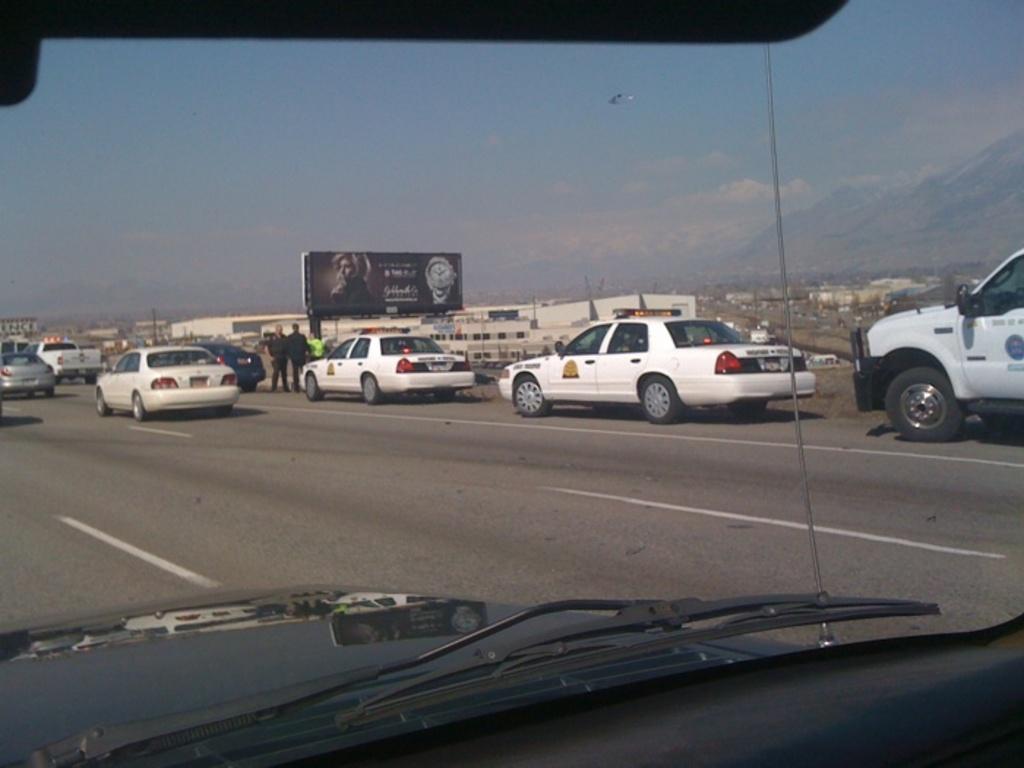In one or two sentences, can you explain what this image depicts? Here in this picture we can see number of cars present on the road over there and we can see people standing here and there and in the far we can see houses present all over there and we can see a banner present in the middle and we can see clouds in the sky. 